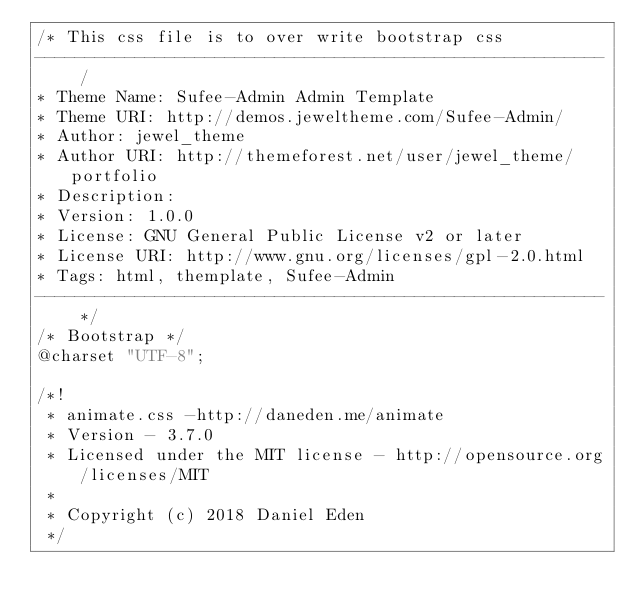Convert code to text. <code><loc_0><loc_0><loc_500><loc_500><_CSS_>/* This css file is to over write bootstrap css
--------------------------------------------------------- /
* Theme Name: Sufee-Admin Admin Template
* Theme URI: http://demos.jeweltheme.com/Sufee-Admin/
* Author: jewel_theme
* Author URI: http://themeforest.net/user/jewel_theme/portfolio
* Description:
* Version: 1.0.0
* License: GNU General Public License v2 or later
* License URI: http://www.gnu.org/licenses/gpl-2.0.html
* Tags: html, themplate, Sufee-Admin
--------------------------------------------------------- */
/* Bootstrap */
@charset "UTF-8";

/*!
 * animate.css -http://daneden.me/animate
 * Version - 3.7.0
 * Licensed under the MIT license - http://opensource.org/licenses/MIT
 *
 * Copyright (c) 2018 Daniel Eden
 */
</code> 